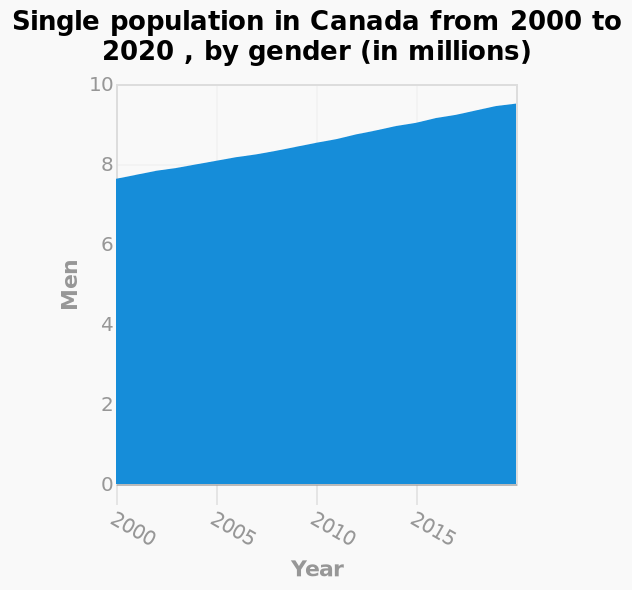<image>
How has the population changed over the years according to the graph? The population has steadily increased through the years. In what intervals is the x-axis measured? The x-axis is measured in 5 yearly intervals. 